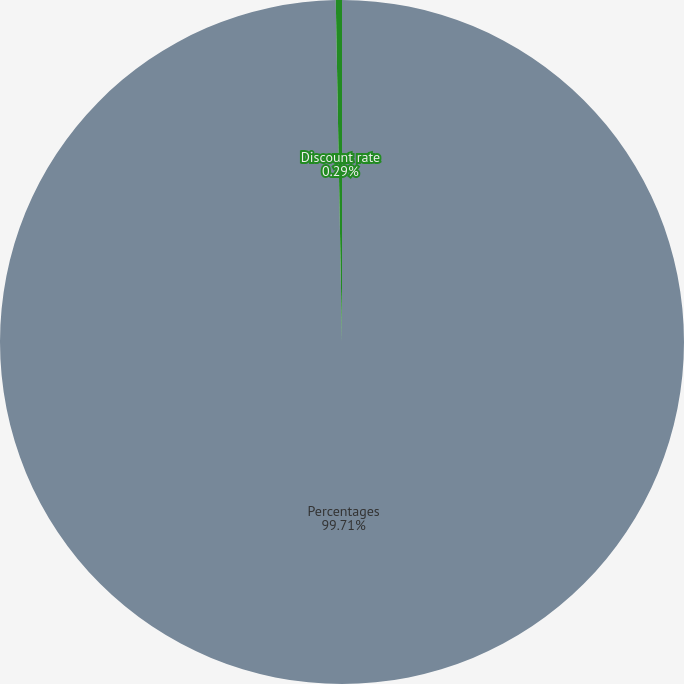Convert chart to OTSL. <chart><loc_0><loc_0><loc_500><loc_500><pie_chart><fcel>Percentages<fcel>Discount rate<nl><fcel>99.71%<fcel>0.29%<nl></chart> 